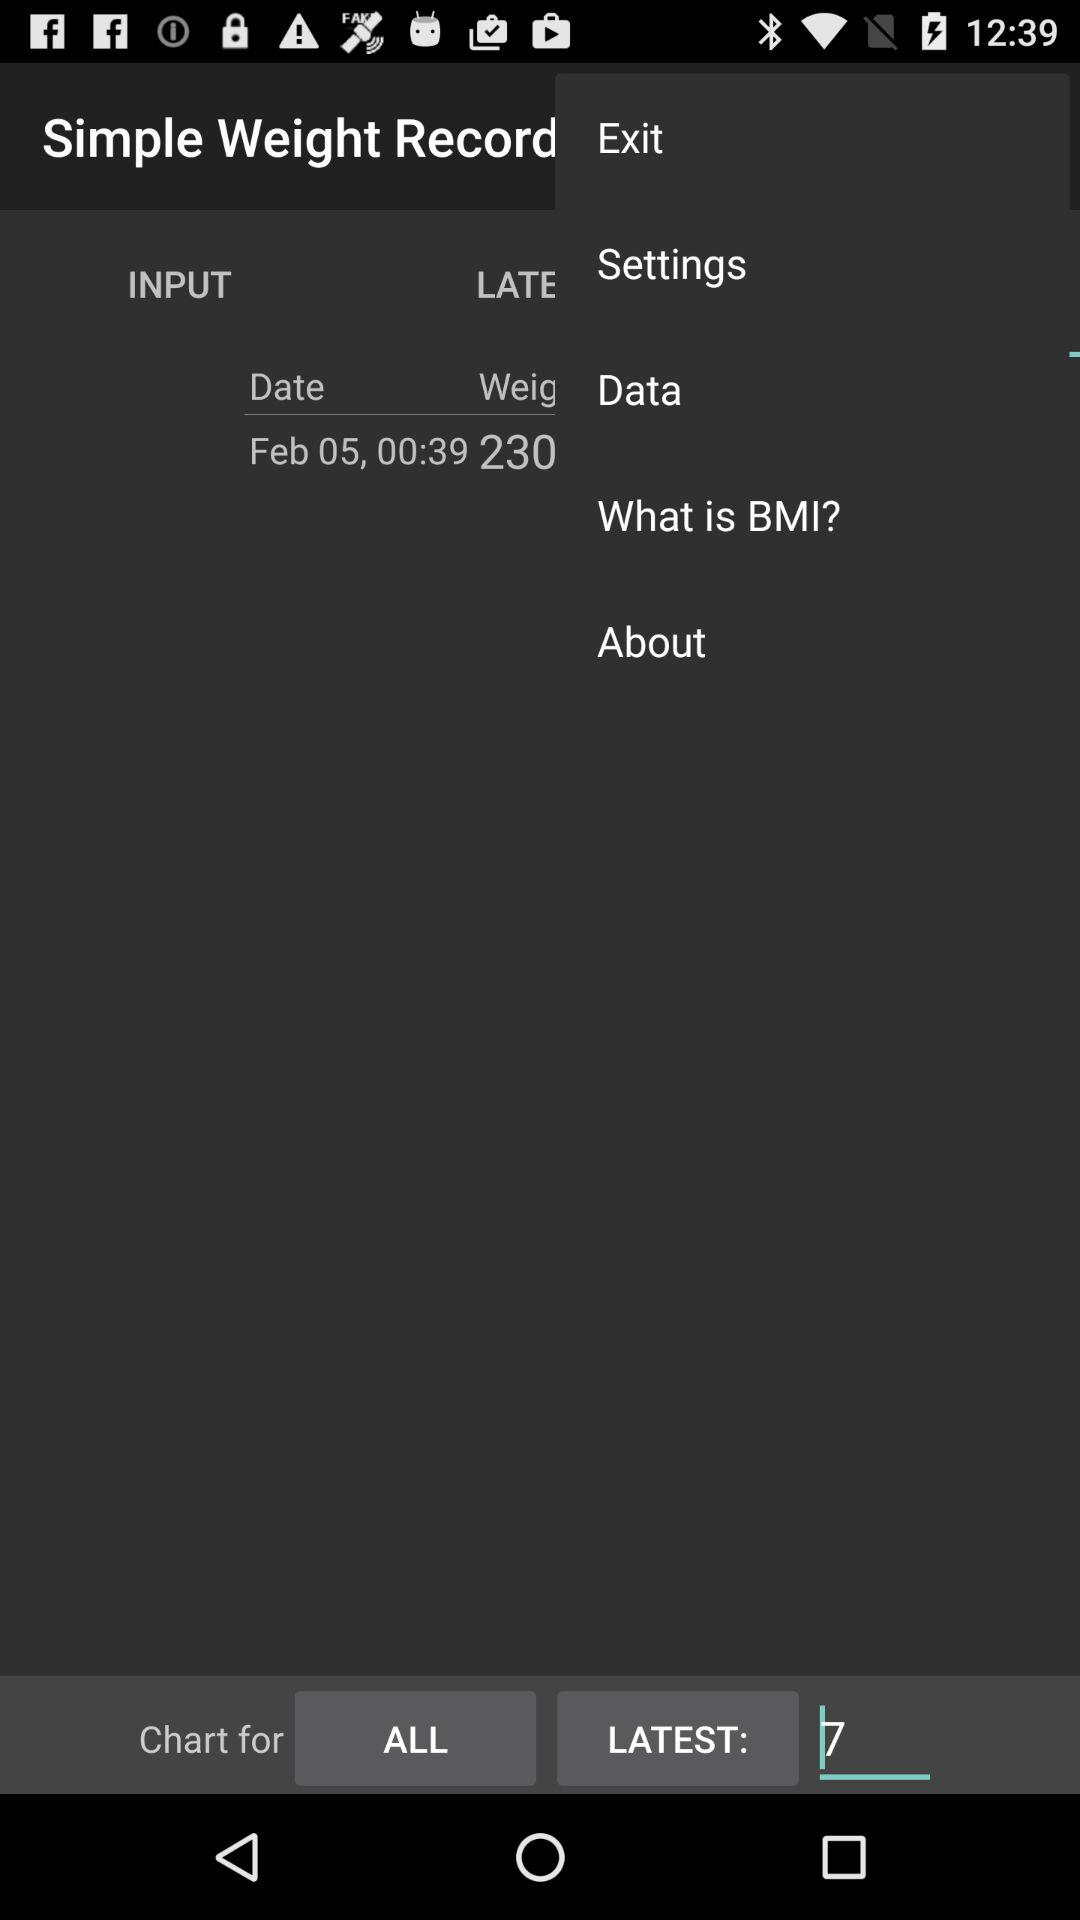What is the selected time? The selected time is 00:39. 